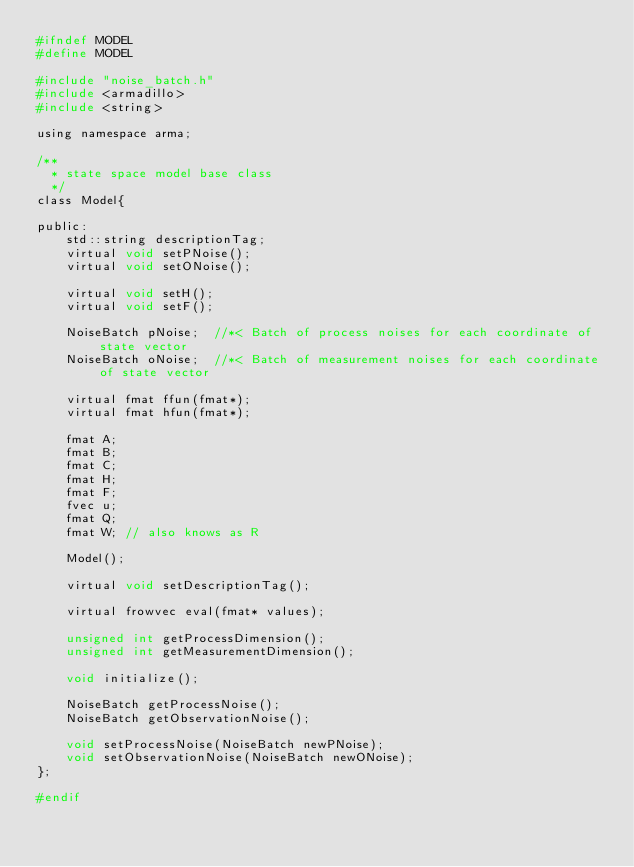<code> <loc_0><loc_0><loc_500><loc_500><_C_>#ifndef MODEL
#define MODEL

#include "noise_batch.h"
#include <armadillo>
#include <string>

using namespace arma;

/**
  * state space model base class
  */
class Model{

public:
    std::string descriptionTag;
    virtual void setPNoise();
    virtual void setONoise();

    virtual void setH();
    virtual void setF();

    NoiseBatch pNoise;	//*< Batch of process noises for each coordinate of state vector
    NoiseBatch oNoise;	//*< Batch of measurement noises for each coordinate of state vector

    virtual fmat ffun(fmat*);
    virtual fmat hfun(fmat*);

    fmat A;
    fmat B;
    fmat C;
    fmat H;
    fmat F;
    fvec u;
    fmat Q;
    fmat W; // also knows as R

    Model();

    virtual void setDescriptionTag();

    virtual frowvec eval(fmat* values);

    unsigned int getProcessDimension();
    unsigned int getMeasurementDimension();

    void initialize();

    NoiseBatch getProcessNoise();
    NoiseBatch getObservationNoise();

    void setProcessNoise(NoiseBatch newPNoise);
    void setObservationNoise(NoiseBatch newONoise);
};

#endif
</code> 